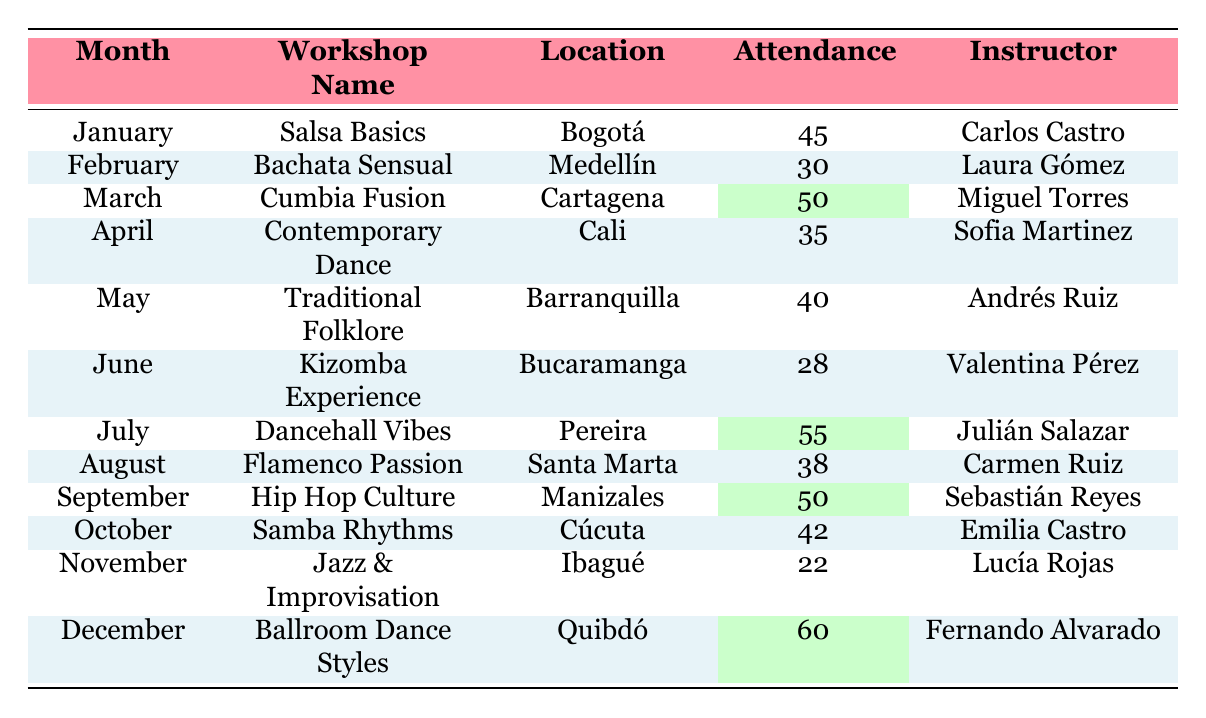What was the highest workshop attendance in 2023? Looking at the attendance numbers, December has the highest attendance at 60 participants for the "Ballroom Dance Styles" workshop.
Answer: 60 Which workshop had the lowest attendance? In the table, the "Jazz & Improvisation" workshop in November had the lowest attendance recorded at 22.
Answer: 22 How many workshops had an attendance of 50 or more? There are three workshops with an attendance of 50 or more: "Cumbia Fusion" in March (50), "Dancehall Vibes" in July (55), and "Ballroom Dance Styles" in December (60). Therefore, the total is 3.
Answer: 3 What was the average attendance for the workshops in the first half of 2023 (January to June)? The attendance values for the first half are: 45, 30, 50, 35, 40, and 28. Their sum is 228, and there are 6 workshops (228 / 6 = 38).
Answer: 38 Did any workshop in August have higher attendance than the one in February? Yes, the "Flamenco Passion" workshop in August had 38 attendees, which is higher than the 30 attendees in the "Bachata Sensual" workshop in February.
Answer: Yes What is the total attendance for all the workshops from January to October? Adding the attendance from January to October gives 45 + 30 + 50 + 35 + 40 + 28 + 55 + 38 + 50 + 42 = 413.
Answer: 413 Which month had the second highest attendance and what was the attendance number? July had the second highest attendance with 55 participants in the "Dancehall Vibes" workshop, after December’s 60 attendees.
Answer: 55 What workshop in March was taught by Miguel Torres? The "Cumbia Fusion" workshop was taught by Miguel Torres in March and had an attendance of 50.
Answer: Cumbia Fusion How many workshops had attendance below the average attendance of the year? The average attendance across all workshops is 41 (490 total attendance across 12 workshops). The workshops below this average are February (30), June (28), and November (22), totaling 3 workshops.
Answer: 3 